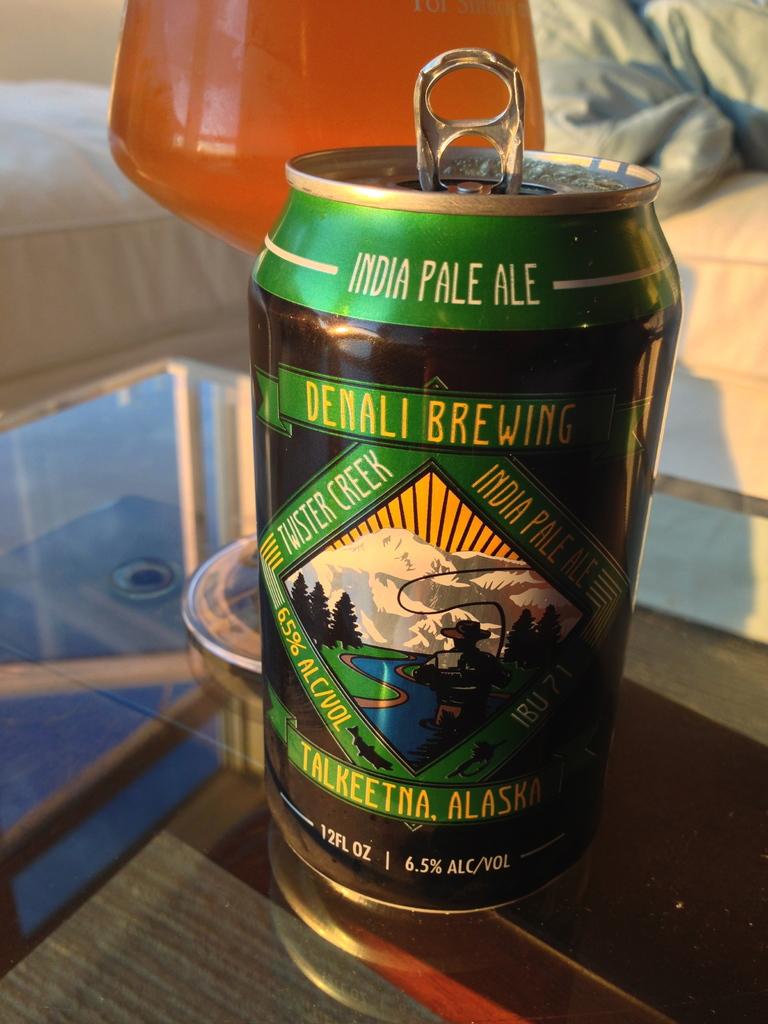How many ounces is this drink?
Your answer should be very brief. 12. What type of ale is this?
Offer a very short reply. India pale ale. 